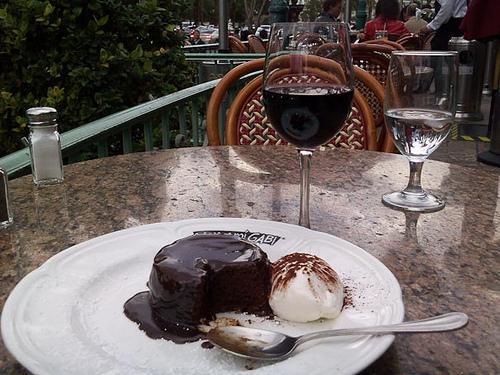How many dining tables are in the photo?
Give a very brief answer. 1. How many wine glasses are there?
Give a very brief answer. 2. 